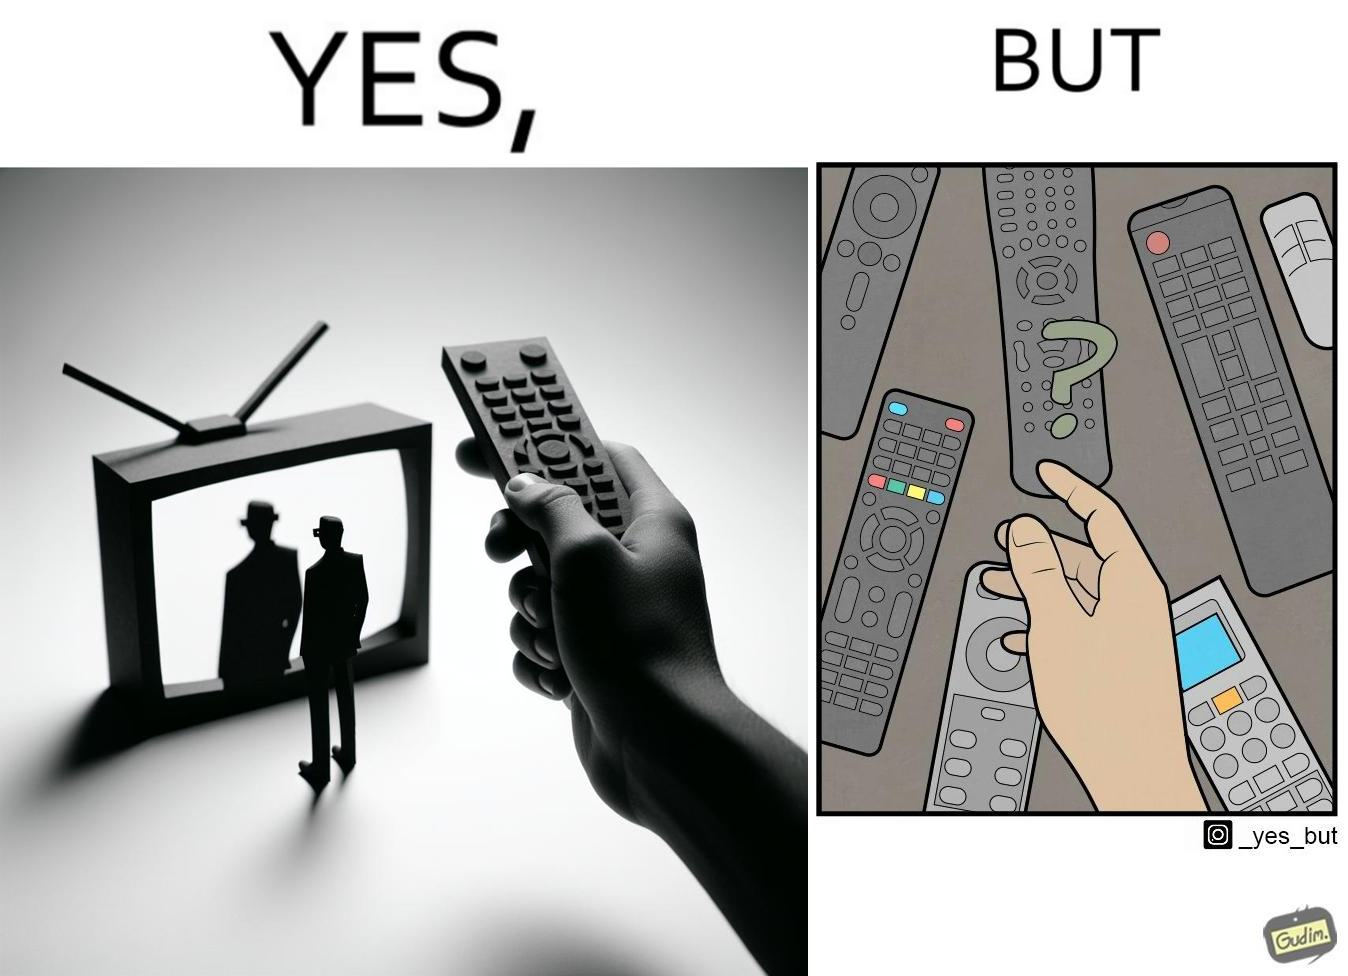Is this image satirical or non-satirical? Yes, this image is satirical. 